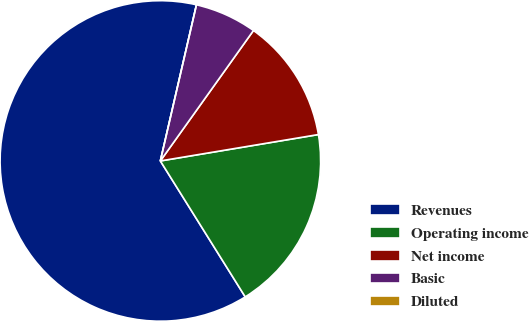Convert chart to OTSL. <chart><loc_0><loc_0><loc_500><loc_500><pie_chart><fcel>Revenues<fcel>Operating income<fcel>Net income<fcel>Basic<fcel>Diluted<nl><fcel>62.5%<fcel>18.75%<fcel>12.5%<fcel>6.25%<fcel>0.0%<nl></chart> 